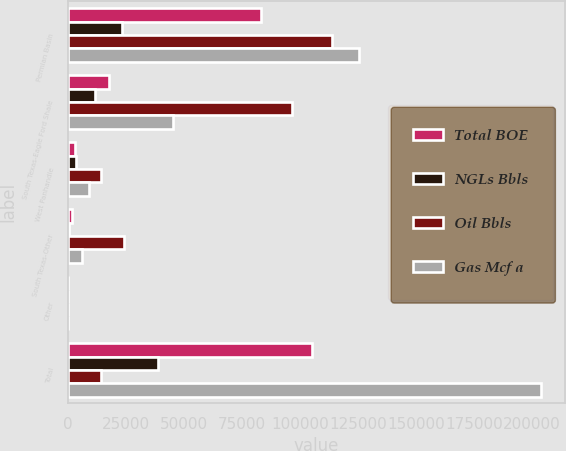Convert chart to OTSL. <chart><loc_0><loc_0><loc_500><loc_500><stacked_bar_chart><ecel><fcel>Permian Basin<fcel>South Texas-Eagle Ford Shale<fcel>West Panhandle<fcel>South Texas-Other<fcel>Other<fcel>Total<nl><fcel>Total BOE<fcel>83046<fcel>17670<fcel>2921<fcel>1709<fcel>1<fcel>105347<nl><fcel>NGLs Bbls<fcel>23306<fcel>11590<fcel>3524<fcel>171<fcel>1<fcel>38592<nl><fcel>Oil Bbls<fcel>113909<fcel>96492<fcel>14252<fcel>24245<fcel>89<fcel>14252<nl><fcel>Gas Mcf a<fcel>125336<fcel>45343<fcel>8820<fcel>5921<fcel>17<fcel>204050<nl></chart> 